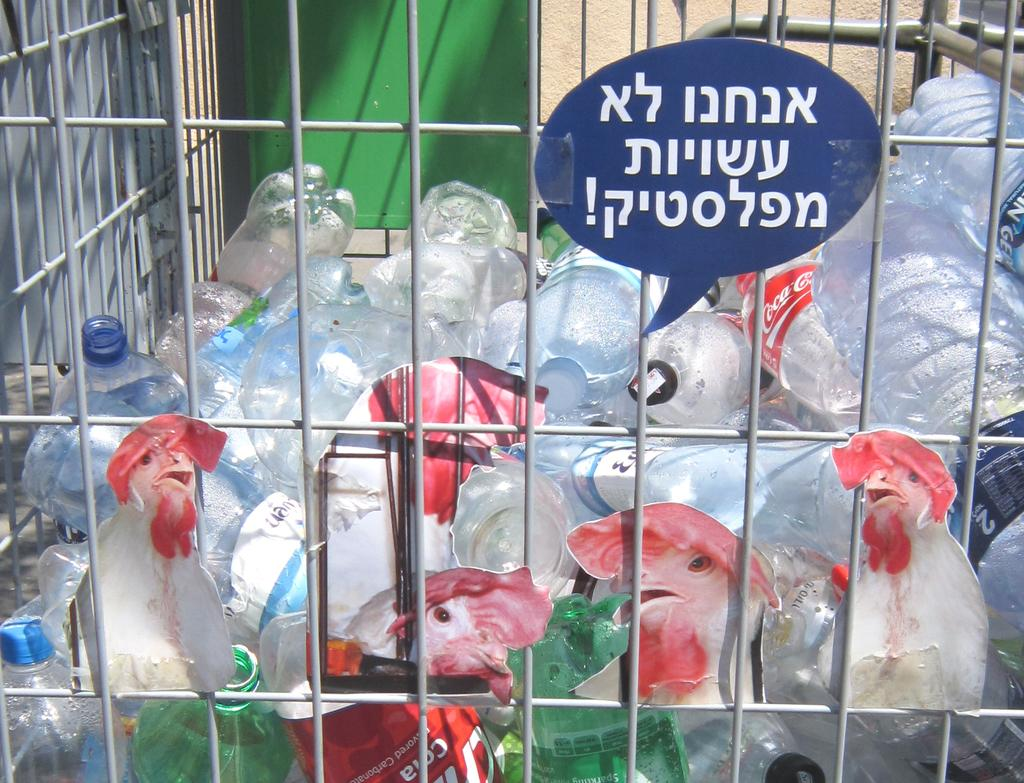What is in the trolley that can be seen in the image? There are bottles and photos of hens in the trolley. Are there any other items in the trolley besides the bottles and photos of hens? Yes, there are other objects in the trolley. What can be observed in the background of the image? The background of the image includes a green and white color wall. What type of birds can be seen flying in the image? There are no birds visible in the image; it only shows a trolley with bottles, photos of hens, and other objects. 